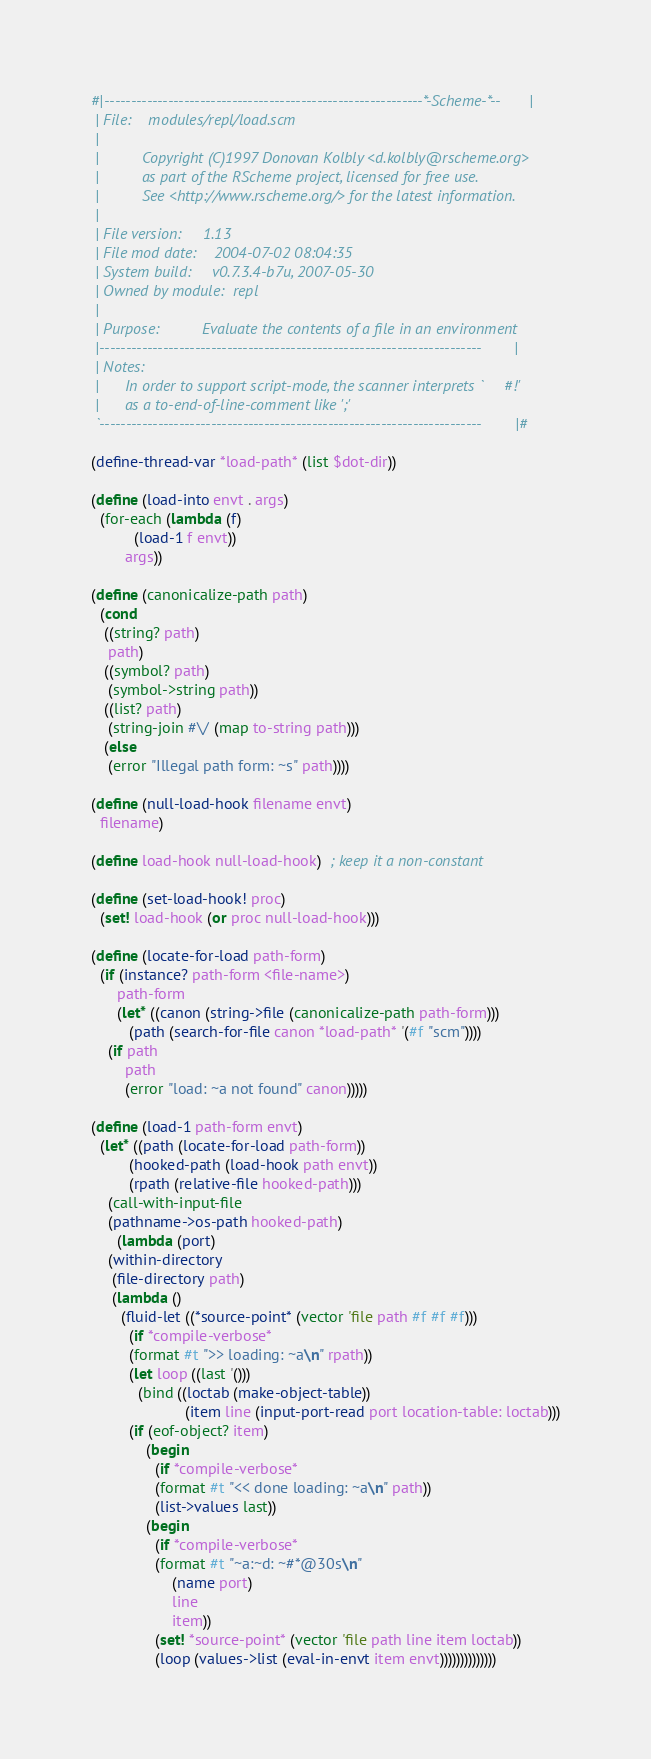Convert code to text. <code><loc_0><loc_0><loc_500><loc_500><_Scheme_>#|------------------------------------------------------------*-Scheme-*--|
 | File:    modules/repl/load.scm
 |
 |          Copyright (C)1997 Donovan Kolbly <d.kolbly@rscheme.org>
 |          as part of the RScheme project, licensed for free use.
 |          See <http://www.rscheme.org/> for the latest information.
 |
 | File version:     1.13
 | File mod date:    2004-07-02 08:04:35
 | System build:     v0.7.3.4-b7u, 2007-05-30
 | Owned by module:  repl
 |
 | Purpose:          Evaluate the contents of a file in an environment
 |------------------------------------------------------------------------|
 | Notes:
 |      In order to support script-mode, the scanner interprets `#!'
 |      as a to-end-of-line-comment like ';'
 `------------------------------------------------------------------------|#

(define-thread-var *load-path* (list $dot-dir))

(define (load-into envt . args)
  (for-each (lambda (f)
	      (load-1 f envt))
	    args))

(define (canonicalize-path path)
  (cond 
   ((string? path)
    path)
   ((symbol? path)
    (symbol->string path))
   ((list? path)
    (string-join #\/ (map to-string path)))
   (else
    (error "Illegal path form: ~s" path))))

(define (null-load-hook filename envt)
  filename)

(define load-hook null-load-hook)  ; keep it a non-constant

(define (set-load-hook! proc)
  (set! load-hook (or proc null-load-hook)))

(define (locate-for-load path-form)
  (if (instance? path-form <file-name>)
      path-form
      (let* ((canon (string->file (canonicalize-path path-form)))
	     (path (search-for-file canon *load-path* '(#f "scm"))))
	(if path
	    path
	    (error "load: ~a not found" canon)))))

(define (load-1 path-form envt)
  (let* ((path (locate-for-load path-form))
         (hooked-path (load-hook path envt))
         (rpath (relative-file hooked-path)))
    (call-with-input-file
	(pathname->os-path hooked-path)
      (lambda (port)
	(within-directory
	 (file-directory path)
	 (lambda ()
	   (fluid-let ((*source-point* (vector 'file path #f #f #f)))
	     (if *compile-verbose*
		 (format #t ">> loading: ~a\n" rpath))
	     (let loop ((last '()))
	       (bind ((loctab (make-object-table))
                      (item line (input-port-read port location-table: loctab)))
		 (if (eof-object? item)
		     (begin
		       (if *compile-verbose*
			   (format #t "<< done loading: ~a\n" path))
		       (list->values last))
		     (begin
		       (if *compile-verbose*
			   (format #t "~a:~d: ~#*@30s\n" 
				   (name port)
				   line 
				   item))
		       (set! *source-point* (vector 'file path line item loctab))
		       (loop (values->list (eval-in-envt item envt))))))))))))))

</code> 